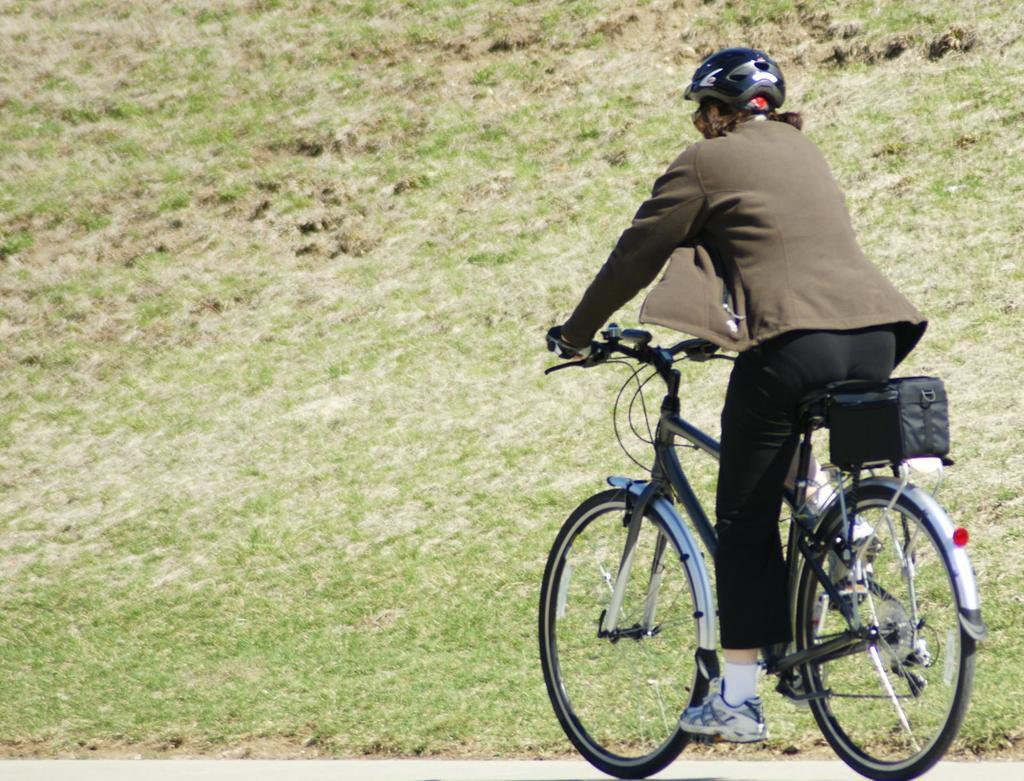What is the person in the image doing? The person is riding a bicycle. What safety precaution is the person taking while riding the bicycle? The person is wearing a helmet. What type of footwear is the person wearing? The person is wearing shoes. What is attached to the backside of the bicycle? There is a bag attached to the backside of the bicycle. What can be seen in the background of the image? The background of the image includes grassy land. What type of straw can be seen in the person's hand in the image? There is no straw present in the person's hand or in the image. What smell is associated with the scene in the image? The image does not convey any specific smells, so it cannot be determined from the image. 